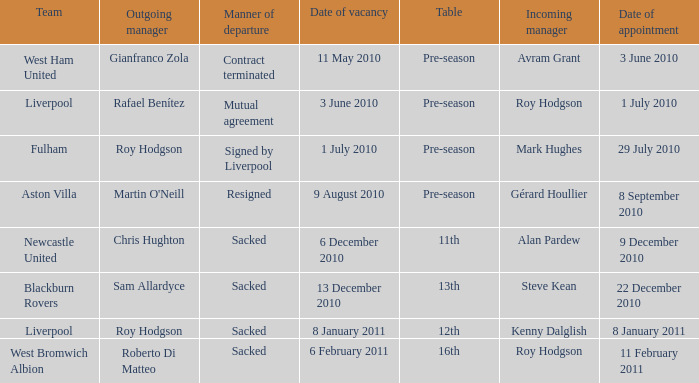What is the table for the team Blackburn Rovers? 13th. 